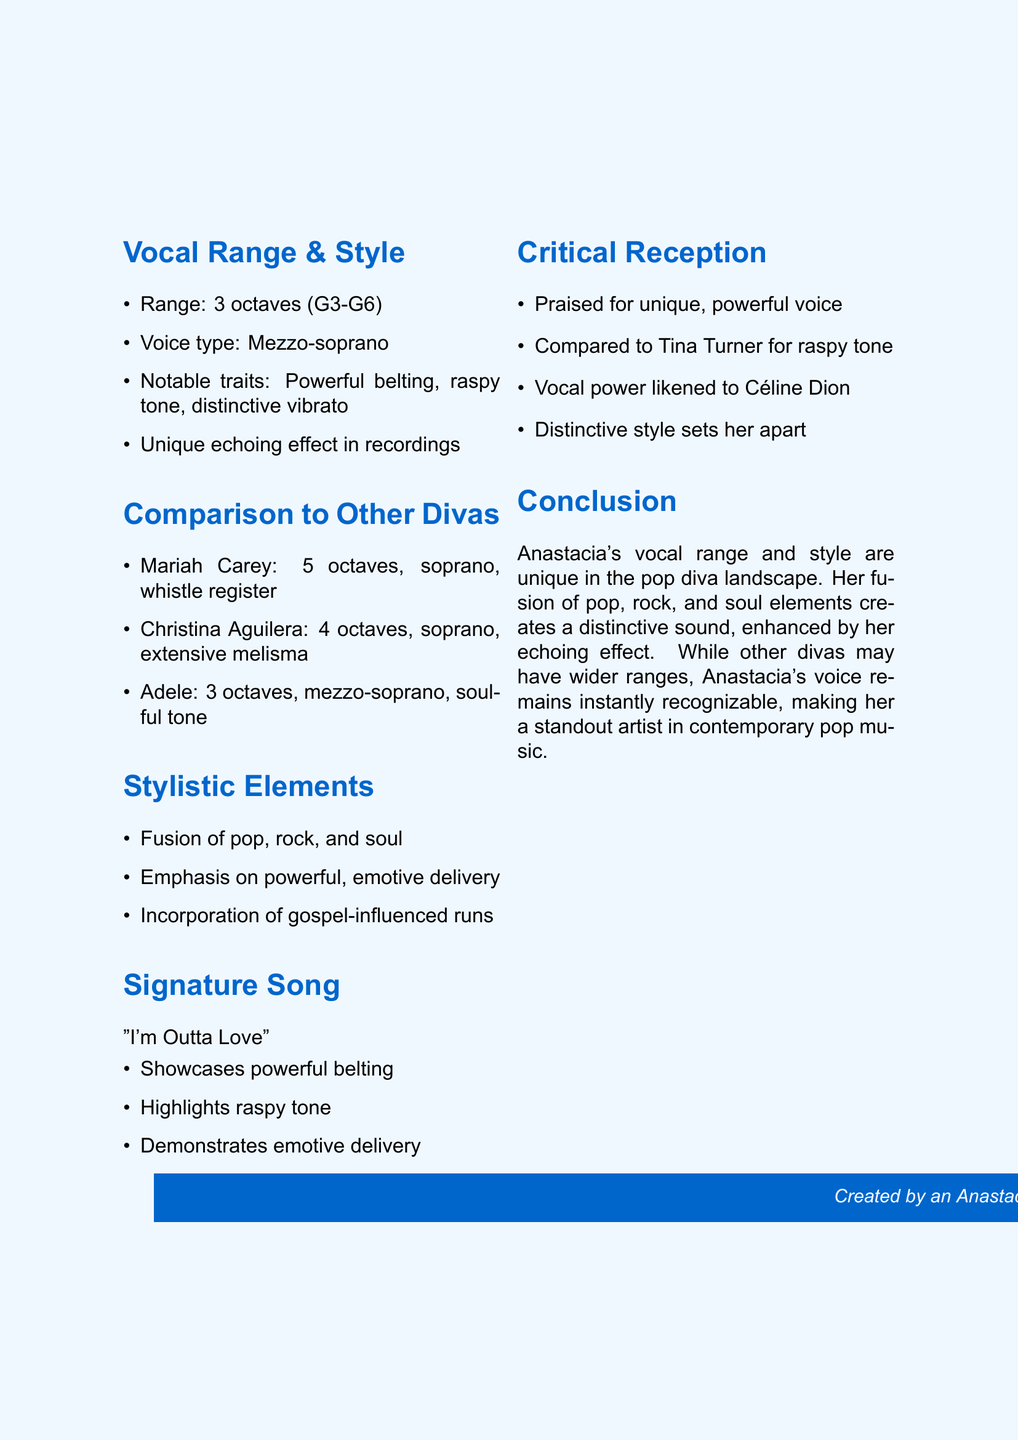What is Anastacia's vocal range? Anastacia's vocal range is specified within the document as 3 octaves, from G3 to G6.
Answer: 3 octaves (G3-G6) What type of voice does Anastacia have? The document describes Anastacia's voice type as mezzo-soprano.
Answer: Mezzo-soprano Which song of Christina Aguilera is mentioned? The document provides specific signature songs for each artist, mentioning "Beautiful" for Christina Aguilera.
Answer: Beautiful How many octaves does Mariah Carey have? The document states that Mariah Carey has a vocal range of 5 octaves.
Answer: 5 octaves What is a notable trait of Christina Aguilera's voice? The document lists extensive use of melisma as a notable trait of Christina Aguilera's voice.
Answer: Extensive use of melisma Which artist is often compared to Anastacia for her raspy tone? The document mentions that Anastacia is often compared to Tina Turner for her raspy tone.
Answer: Tina Turner What is included in the stylistic elements of Anastacia? The document states that Anastacia's stylistic elements include a fusion of pop, rock, and soul.
Answer: Fusion of pop, rock, and soul What does the critical reception say about Anastacia's vocal power? The document describes Anastacia's vocal power as unique and powerful, emphasizing her ability to convey emotion.
Answer: Unique, powerful voice What type of music fusion is associated with Adele in the document? The document notes that Adele's style is characterized as a soul and pop crossover.
Answer: Soul and pop crossover 